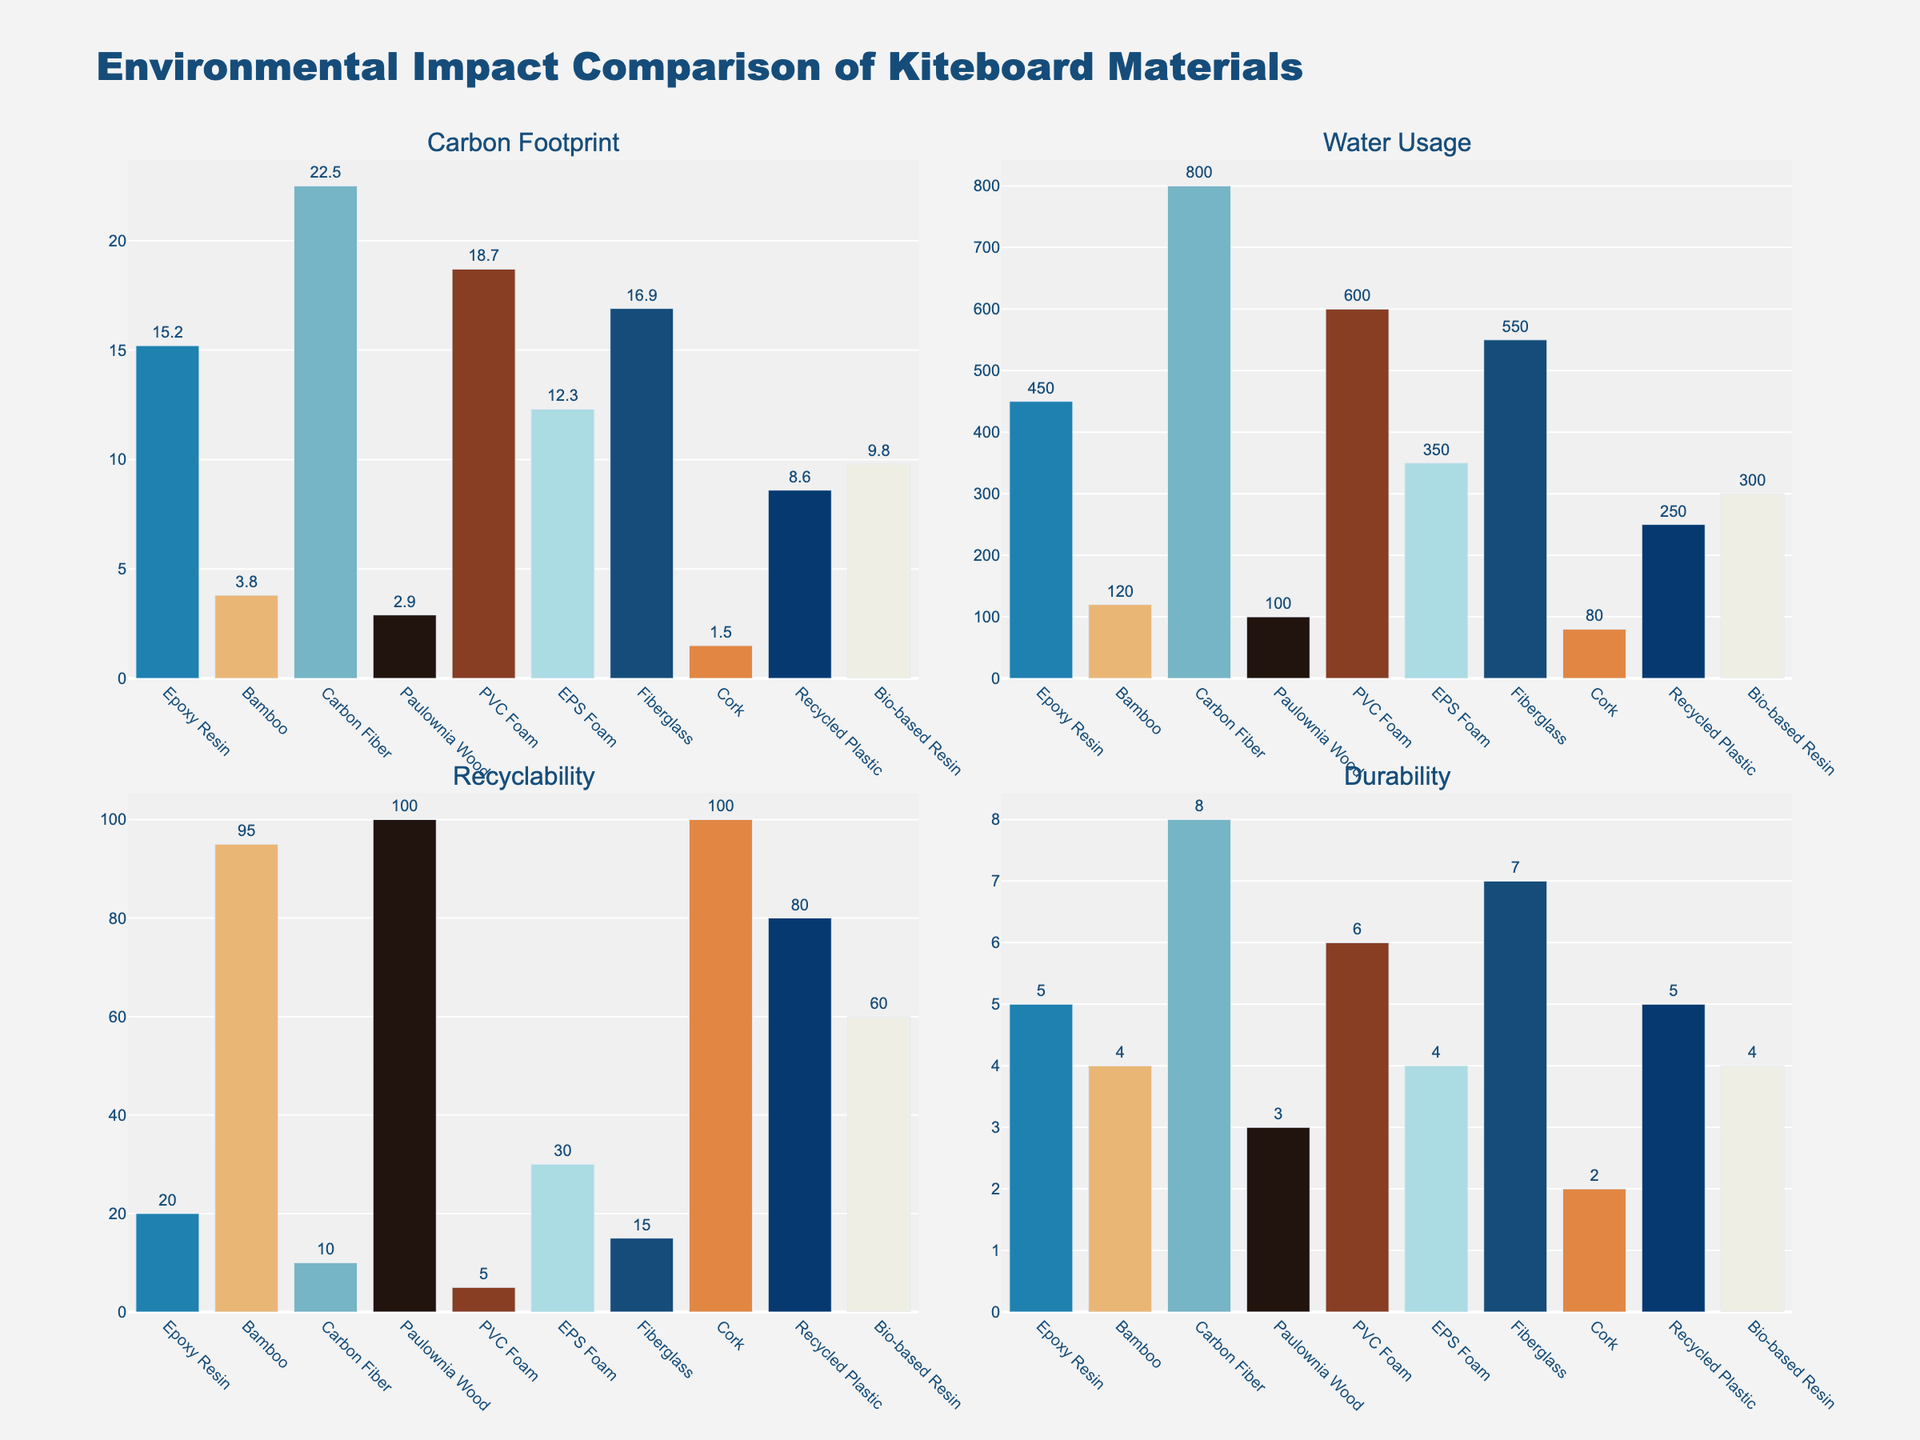What material has the highest carbon footprint? By looking at the bars under "Carbon Footprint", the tallest bar indicates the highest carbon footprint. The material with the highest bar is Carbon Fiber.
Answer: Carbon Fiber Which material uses the least amount of water? The lowest bar under "Water Usage" indicates the least water usage. The shortest bar corresponds to Cork.
Answer: Cork Which materials have 100% recyclability? In the "Recyclability" subplot, the materials with bars reaching the maximum value of 100% are Paulownia Wood and Cork.
Answer: Paulownia Wood and Cork What is the combined durability of Carbon Fiber and PVC Foam? Looking at the "Durability" subplot, Carbon Fiber has a durability of 8 years and PVC Foam has 6 years. Adding these two values gives us 8 + 6 = 14 years.
Answer: 14 years Which material shows the greatest difference in water usage compared to EPS Foam? In the "Water Usage" subplot, EPS Foam uses 350 liters. Comparing this value with the others, Carbon Fiber uses 800 liters, creating the greatest difference of 800 - 350 = 450 liters.
Answer: Carbon Fiber What is the average carbon footprint of Bamboo, Paulownia Wood, and Cork? The carbon footprints are: Bamboo = 3.8 kg CO2e, Paulownia Wood = 2.9 kg CO2e, and Cork = 1.5 kg CO2e. Adding these values gives us 3.8 + 2.9 + 1.5 = 8.2 kg CO2e. The average is 8.2 / 3 ≈ 2.73 kg CO2e.
Answer: 2.73 kg CO2e Among Bio-based Resin and Fiberglass, which material is more durable? In the "Durability" subplot, Bio-based Resin has 4 years, and Fiberglass has 7 years of durability. Fiberglass is more durable.
Answer: Fiberglass Which material has a higher recyclability: Recycled Plastic or Epoxy Resin? Looking at the "Recyclability" subplot, Recycled Plastic has a recyclability of 80%, and Epoxy Resin has 20%. Recycled Plastic has higher recyclability.
Answer: Recycled Plastic How does the water usage of Bamboo compare to that of Epoxy Resin? In the "Water Usage" subplot, Bamboo uses 120 liters, while Epoxy Resin uses 450 liters of water. Bamboo uses less water.
Answer: Bamboo uses less water Which material has the second longest durability? In the "Durability" subplot, the longest durability is Carbon Fiber with 8 years, and the second longest is Fiberglass with 7 years.
Answer: Fiberglass 